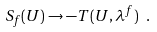<formula> <loc_0><loc_0><loc_500><loc_500>S _ { f } ( U ) \rightarrow - T ( U , \lambda ^ { f } ) \ .</formula> 